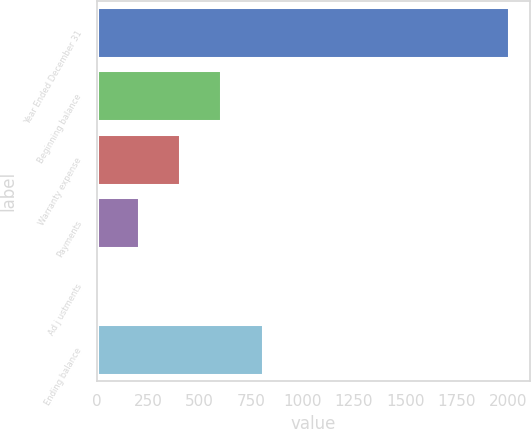Convert chart. <chart><loc_0><loc_0><loc_500><loc_500><bar_chart><fcel>Year Ended December 31<fcel>Beginning balance<fcel>Warranty expense<fcel>Payments<fcel>Ad j ustments<fcel>Ending balance<nl><fcel>2007<fcel>605.6<fcel>405.4<fcel>205.2<fcel>5<fcel>805.8<nl></chart> 